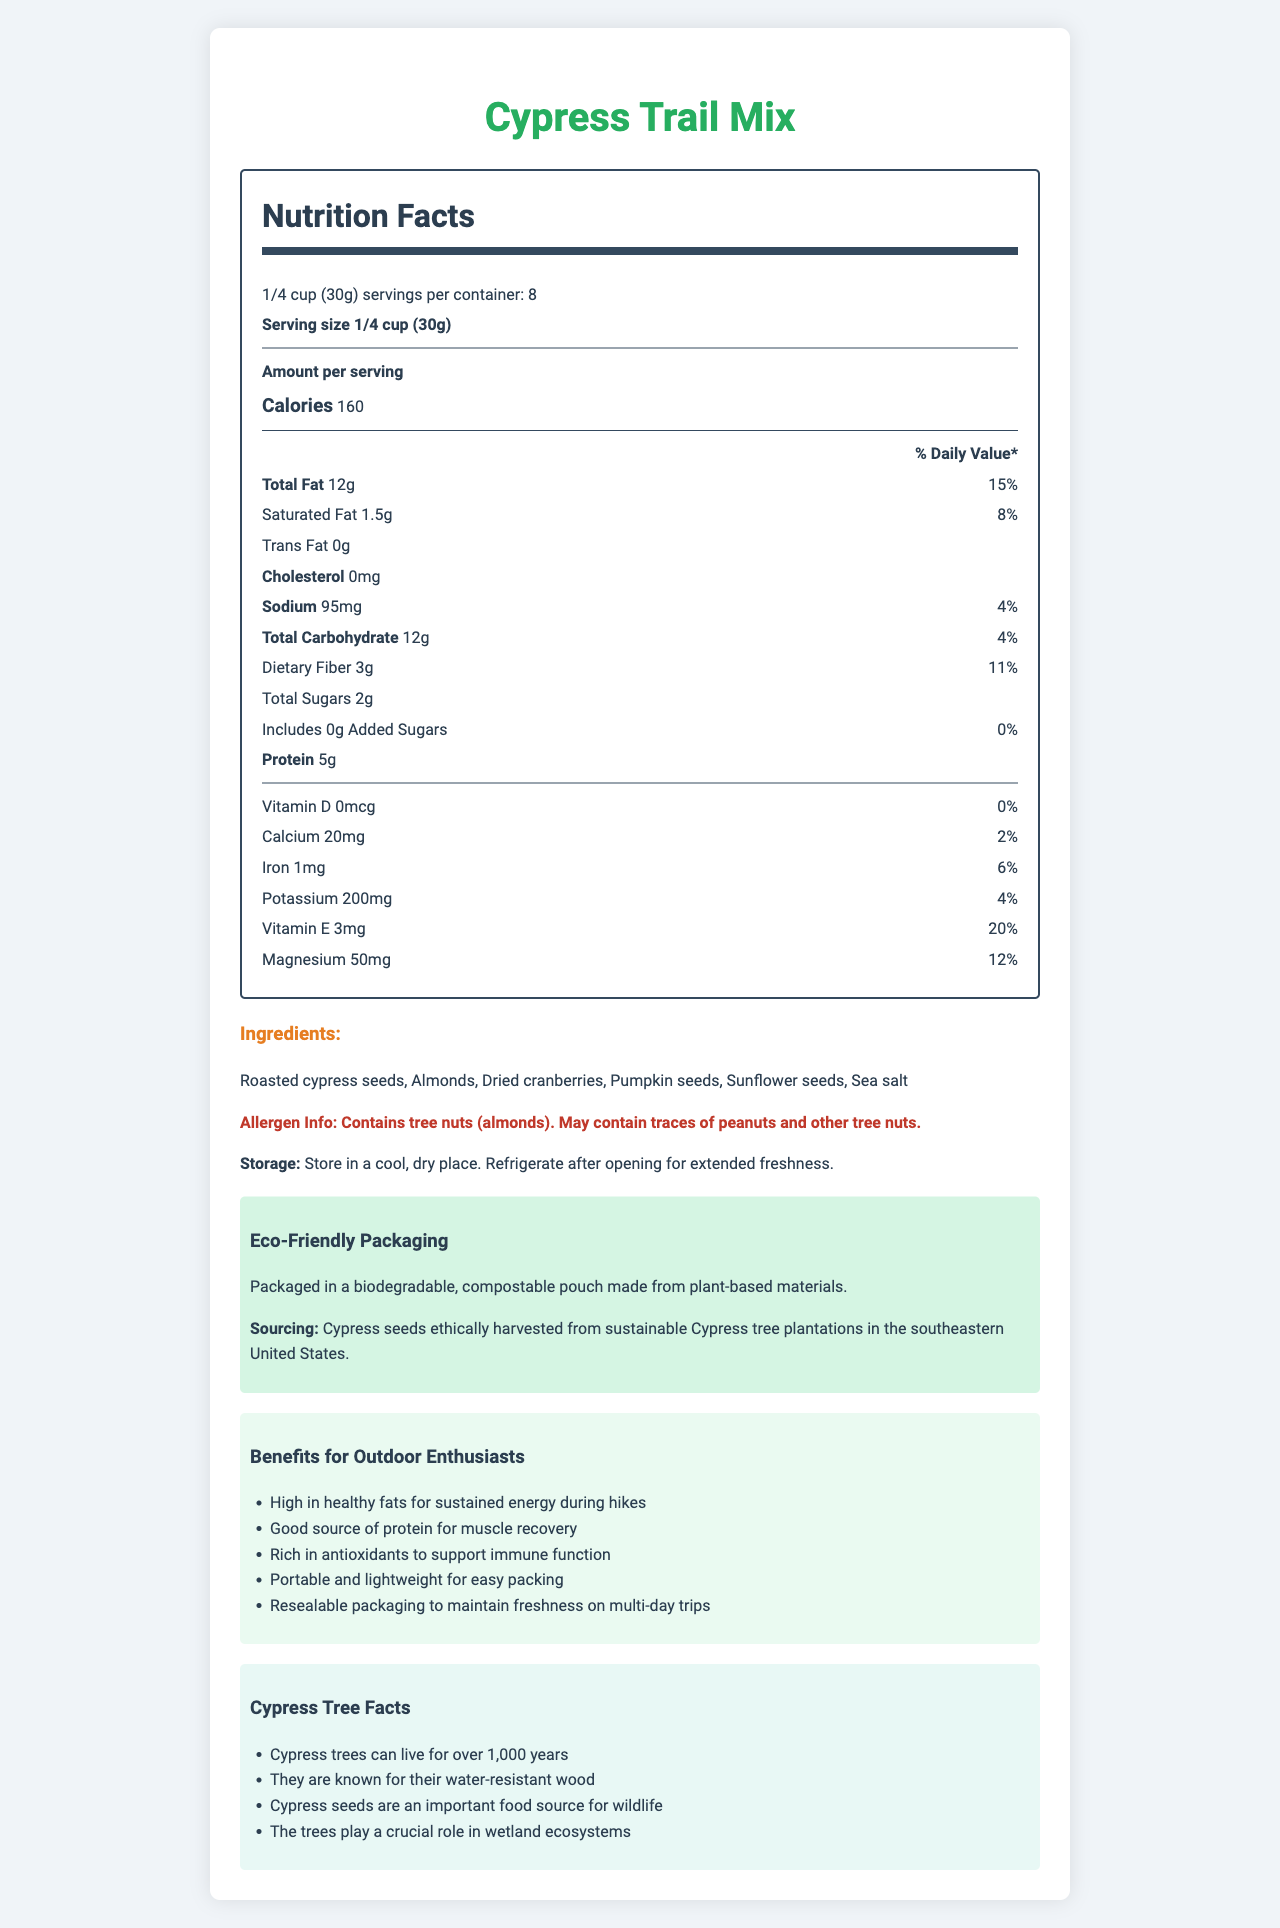what is the serving size of Cypress Trail Mix? The serving size is explicitly listed as "1/4 cup (30g)" at the top of the Nutrition Facts label.
Answer: 1/4 cup (30g) how many calories are in one serving of Cypress Trail Mix? The Nutrition Facts label shows that each serving contains 160 calories.
Answer: 160 what percentage of the daily value of total fat does one serving of Cypress Trail Mix provide? The label indicates that the total fat content is 12g, which is 15% of the daily value.
Answer: 15% who can consume this product if they have a nut allergy? According to the allergen information provided, the product contains tree nuts (almonds) and may contain traces of peanuts and other tree nuts.
Answer: May contain traces of peanuts and other tree nuts what vitamins and minerals are in Cypress Trail Mix? The Nutrition Facts label lists Vitamin D, Vitamin E, Calcium, Iron, Potassium, and Magnesium.
Answer: Vitamins: Vitamin D and Vitamin E; Minerals: Calcium, Iron, Potassium, Magnesium how many servings are there per container of Cypress Trail Mix? The label mentions "8 servings per container."
Answer: 8 what are the main ingredients in the Cypress Trail Mix? The ingredients list is found in the ingredients section under Nutrition Facts.
Answer: Roasted cypress seeds, Almonds, Dried cranberries, Pumpkin seeds, Sunflower seeds, Sea salt how much protein is in one serving of Cypress Trail Mix? The Nutrition Facts label states that there are 5g of protein per serving.
Answer: 5g **Multiple-choice**: What is the sodium content in one serving of Cypress Trail Mix?  
A. 95mg  
B. 75mg  
C. 50mg  
D. 120mg The Nutrition Facts label displays that the sodium content per serving is 95mg.
Answer: A **Multiple-choice**: Which nutrient has the highest daily value percentage in one serving of Cypress Trail Mix?  
I. Vitamin E  
II. Magnesium  
III. Iron  
IV. Sodium The highest daily value percentage is for Vitamin E, which provides 20% of the daily value according to the label.
Answer: I **Yes/No (True/False)**: Does Cypress Trail Mix contain any added sugars? The label states that the amount of added sugars is 0g, with 0% daily value.
Answer: No summarize the key benefits of the Cypress Trail Mix for outdoor enthusiasts. The document lists several benefits of the Cypress Trail Mix for outdoor enthusiasts, including high energy, protein content, antioxidants, portability, and convenient packaging.
Answer: The Cypress Trail Mix is high in healthy fats for sustained energy, good source of protein for muscle recovery, rich in antioxidants, portable and lightweight, with resealable packaging for freshness on multi-day trips. **Unanswerable**: Can Cypress seeds be used to grow Cypress trees for my garden? The document provides nutrition and ingredient details, benefits, and tree facts, but does not mention the use of Cypress seeds for growing trees.
Answer: Not enough information 